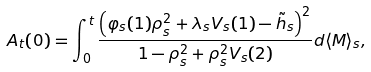<formula> <loc_0><loc_0><loc_500><loc_500>A _ { t } ( 0 ) = \int _ { 0 } ^ { t } \frac { \left ( \varphi _ { s } ( 1 ) \rho _ { s } ^ { 2 } + \lambda _ { s } V _ { s } ( 1 ) - \tilde { h } _ { s } \right ) ^ { 2 } } { 1 - \rho _ { s } ^ { 2 } + \rho _ { s } ^ { 2 } V _ { s } ( 2 ) } d \langle M \rangle _ { s } ,</formula> 